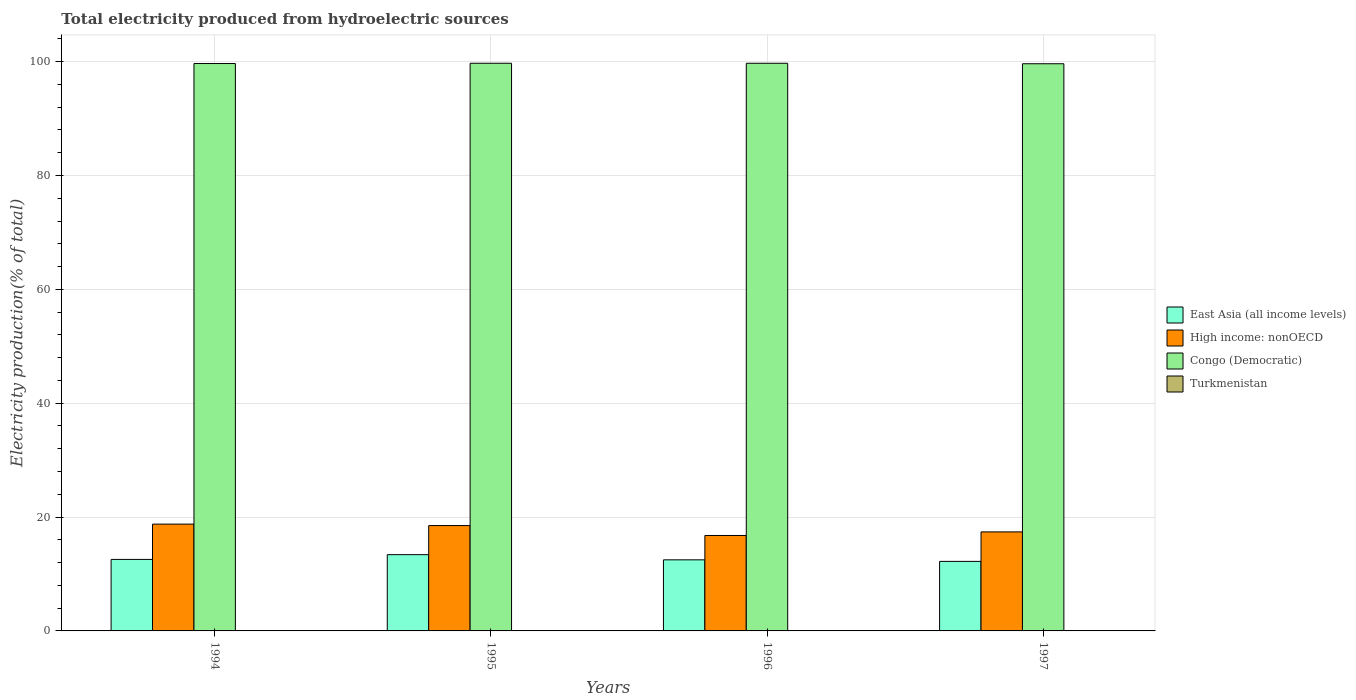How many groups of bars are there?
Provide a succinct answer. 4. Are the number of bars per tick equal to the number of legend labels?
Keep it short and to the point. Yes. How many bars are there on the 2nd tick from the right?
Offer a very short reply. 4. What is the label of the 4th group of bars from the left?
Provide a succinct answer. 1997. What is the total electricity produced in High income: nonOECD in 1995?
Provide a short and direct response. 18.5. Across all years, what is the maximum total electricity produced in High income: nonOECD?
Offer a very short reply. 18.76. Across all years, what is the minimum total electricity produced in Turkmenistan?
Your answer should be compact. 0.04. In which year was the total electricity produced in Congo (Democratic) minimum?
Give a very brief answer. 1997. What is the total total electricity produced in Turkmenistan in the graph?
Your answer should be very brief. 0.18. What is the difference between the total electricity produced in East Asia (all income levels) in 1994 and that in 1996?
Your answer should be compact. 0.08. What is the difference between the total electricity produced in High income: nonOECD in 1997 and the total electricity produced in Turkmenistan in 1995?
Your answer should be compact. 17.35. What is the average total electricity produced in East Asia (all income levels) per year?
Give a very brief answer. 12.66. In the year 1995, what is the difference between the total electricity produced in East Asia (all income levels) and total electricity produced in Congo (Democratic)?
Provide a short and direct response. -86.31. In how many years, is the total electricity produced in Turkmenistan greater than 8 %?
Ensure brevity in your answer.  0. What is the ratio of the total electricity produced in Turkmenistan in 1996 to that in 1997?
Your response must be concise. 0.94. Is the total electricity produced in East Asia (all income levels) in 1995 less than that in 1997?
Your response must be concise. No. Is the difference between the total electricity produced in East Asia (all income levels) in 1994 and 1995 greater than the difference between the total electricity produced in Congo (Democratic) in 1994 and 1995?
Your answer should be compact. No. What is the difference between the highest and the second highest total electricity produced in East Asia (all income levels)?
Your answer should be very brief. 0.83. What is the difference between the highest and the lowest total electricity produced in Turkmenistan?
Make the answer very short. 0.01. Is it the case that in every year, the sum of the total electricity produced in East Asia (all income levels) and total electricity produced in Turkmenistan is greater than the sum of total electricity produced in High income: nonOECD and total electricity produced in Congo (Democratic)?
Provide a short and direct response. No. What does the 2nd bar from the left in 1996 represents?
Your answer should be compact. High income: nonOECD. What does the 4th bar from the right in 1995 represents?
Give a very brief answer. East Asia (all income levels). Is it the case that in every year, the sum of the total electricity produced in High income: nonOECD and total electricity produced in East Asia (all income levels) is greater than the total electricity produced in Congo (Democratic)?
Offer a very short reply. No. How many bars are there?
Offer a very short reply. 16. Does the graph contain grids?
Provide a succinct answer. Yes. Where does the legend appear in the graph?
Your answer should be very brief. Center right. How many legend labels are there?
Make the answer very short. 4. What is the title of the graph?
Give a very brief answer. Total electricity produced from hydroelectric sources. Does "Philippines" appear as one of the legend labels in the graph?
Offer a terse response. No. What is the label or title of the Y-axis?
Provide a succinct answer. Electricity production(% of total). What is the Electricity production(% of total) in East Asia (all income levels) in 1994?
Ensure brevity in your answer.  12.56. What is the Electricity production(% of total) in High income: nonOECD in 1994?
Your answer should be very brief. 18.76. What is the Electricity production(% of total) in Congo (Democratic) in 1994?
Offer a terse response. 99.66. What is the Electricity production(% of total) in Turkmenistan in 1994?
Keep it short and to the point. 0.04. What is the Electricity production(% of total) of East Asia (all income levels) in 1995?
Offer a terse response. 13.39. What is the Electricity production(% of total) in High income: nonOECD in 1995?
Your answer should be very brief. 18.5. What is the Electricity production(% of total) of Congo (Democratic) in 1995?
Make the answer very short. 99.71. What is the Electricity production(% of total) of Turkmenistan in 1995?
Offer a very short reply. 0.04. What is the Electricity production(% of total) in East Asia (all income levels) in 1996?
Keep it short and to the point. 12.48. What is the Electricity production(% of total) of High income: nonOECD in 1996?
Offer a very short reply. 16.76. What is the Electricity production(% of total) in Congo (Democratic) in 1996?
Offer a terse response. 99.71. What is the Electricity production(% of total) in Turkmenistan in 1996?
Offer a terse response. 0.05. What is the Electricity production(% of total) of East Asia (all income levels) in 1997?
Provide a short and direct response. 12.22. What is the Electricity production(% of total) in High income: nonOECD in 1997?
Ensure brevity in your answer.  17.39. What is the Electricity production(% of total) in Congo (Democratic) in 1997?
Offer a very short reply. 99.62. What is the Electricity production(% of total) of Turkmenistan in 1997?
Provide a succinct answer. 0.05. Across all years, what is the maximum Electricity production(% of total) of East Asia (all income levels)?
Provide a short and direct response. 13.39. Across all years, what is the maximum Electricity production(% of total) of High income: nonOECD?
Offer a terse response. 18.76. Across all years, what is the maximum Electricity production(% of total) of Congo (Democratic)?
Your answer should be very brief. 99.71. Across all years, what is the maximum Electricity production(% of total) in Turkmenistan?
Ensure brevity in your answer.  0.05. Across all years, what is the minimum Electricity production(% of total) in East Asia (all income levels)?
Offer a terse response. 12.22. Across all years, what is the minimum Electricity production(% of total) of High income: nonOECD?
Your response must be concise. 16.76. Across all years, what is the minimum Electricity production(% of total) of Congo (Democratic)?
Give a very brief answer. 99.62. Across all years, what is the minimum Electricity production(% of total) of Turkmenistan?
Your answer should be compact. 0.04. What is the total Electricity production(% of total) of East Asia (all income levels) in the graph?
Give a very brief answer. 50.66. What is the total Electricity production(% of total) in High income: nonOECD in the graph?
Offer a terse response. 71.42. What is the total Electricity production(% of total) of Congo (Democratic) in the graph?
Offer a very short reply. 398.7. What is the total Electricity production(% of total) of Turkmenistan in the graph?
Ensure brevity in your answer.  0.18. What is the difference between the Electricity production(% of total) of East Asia (all income levels) in 1994 and that in 1995?
Give a very brief answer. -0.83. What is the difference between the Electricity production(% of total) of High income: nonOECD in 1994 and that in 1995?
Your answer should be compact. 0.26. What is the difference between the Electricity production(% of total) in Congo (Democratic) in 1994 and that in 1995?
Give a very brief answer. -0.05. What is the difference between the Electricity production(% of total) in Turkmenistan in 1994 and that in 1995?
Provide a short and direct response. -0. What is the difference between the Electricity production(% of total) in East Asia (all income levels) in 1994 and that in 1996?
Make the answer very short. 0.08. What is the difference between the Electricity production(% of total) in High income: nonOECD in 1994 and that in 1996?
Offer a very short reply. 2. What is the difference between the Electricity production(% of total) of Congo (Democratic) in 1994 and that in 1996?
Offer a very short reply. -0.04. What is the difference between the Electricity production(% of total) in Turkmenistan in 1994 and that in 1996?
Give a very brief answer. -0.01. What is the difference between the Electricity production(% of total) in East Asia (all income levels) in 1994 and that in 1997?
Your answer should be compact. 0.35. What is the difference between the Electricity production(% of total) in High income: nonOECD in 1994 and that in 1997?
Offer a terse response. 1.37. What is the difference between the Electricity production(% of total) of Congo (Democratic) in 1994 and that in 1997?
Make the answer very short. 0.04. What is the difference between the Electricity production(% of total) in Turkmenistan in 1994 and that in 1997?
Ensure brevity in your answer.  -0.01. What is the difference between the Electricity production(% of total) of East Asia (all income levels) in 1995 and that in 1996?
Your answer should be compact. 0.91. What is the difference between the Electricity production(% of total) of High income: nonOECD in 1995 and that in 1996?
Your response must be concise. 1.74. What is the difference between the Electricity production(% of total) of Congo (Democratic) in 1995 and that in 1996?
Your response must be concise. 0. What is the difference between the Electricity production(% of total) of Turkmenistan in 1995 and that in 1996?
Keep it short and to the point. -0.01. What is the difference between the Electricity production(% of total) of East Asia (all income levels) in 1995 and that in 1997?
Ensure brevity in your answer.  1.18. What is the difference between the Electricity production(% of total) of High income: nonOECD in 1995 and that in 1997?
Your answer should be very brief. 1.11. What is the difference between the Electricity production(% of total) in Congo (Democratic) in 1995 and that in 1997?
Make the answer very short. 0.09. What is the difference between the Electricity production(% of total) of Turkmenistan in 1995 and that in 1997?
Your answer should be compact. -0.01. What is the difference between the Electricity production(% of total) in East Asia (all income levels) in 1996 and that in 1997?
Provide a succinct answer. 0.27. What is the difference between the Electricity production(% of total) of High income: nonOECD in 1996 and that in 1997?
Keep it short and to the point. -0.63. What is the difference between the Electricity production(% of total) of Congo (Democratic) in 1996 and that in 1997?
Keep it short and to the point. 0.08. What is the difference between the Electricity production(% of total) in Turkmenistan in 1996 and that in 1997?
Provide a succinct answer. -0. What is the difference between the Electricity production(% of total) in East Asia (all income levels) in 1994 and the Electricity production(% of total) in High income: nonOECD in 1995?
Offer a terse response. -5.94. What is the difference between the Electricity production(% of total) of East Asia (all income levels) in 1994 and the Electricity production(% of total) of Congo (Democratic) in 1995?
Give a very brief answer. -87.15. What is the difference between the Electricity production(% of total) in East Asia (all income levels) in 1994 and the Electricity production(% of total) in Turkmenistan in 1995?
Offer a very short reply. 12.52. What is the difference between the Electricity production(% of total) in High income: nonOECD in 1994 and the Electricity production(% of total) in Congo (Democratic) in 1995?
Give a very brief answer. -80.95. What is the difference between the Electricity production(% of total) of High income: nonOECD in 1994 and the Electricity production(% of total) of Turkmenistan in 1995?
Provide a short and direct response. 18.72. What is the difference between the Electricity production(% of total) of Congo (Democratic) in 1994 and the Electricity production(% of total) of Turkmenistan in 1995?
Provide a succinct answer. 99.62. What is the difference between the Electricity production(% of total) of East Asia (all income levels) in 1994 and the Electricity production(% of total) of High income: nonOECD in 1996?
Ensure brevity in your answer.  -4.2. What is the difference between the Electricity production(% of total) in East Asia (all income levels) in 1994 and the Electricity production(% of total) in Congo (Democratic) in 1996?
Keep it short and to the point. -87.14. What is the difference between the Electricity production(% of total) in East Asia (all income levels) in 1994 and the Electricity production(% of total) in Turkmenistan in 1996?
Your answer should be compact. 12.51. What is the difference between the Electricity production(% of total) of High income: nonOECD in 1994 and the Electricity production(% of total) of Congo (Democratic) in 1996?
Keep it short and to the point. -80.95. What is the difference between the Electricity production(% of total) in High income: nonOECD in 1994 and the Electricity production(% of total) in Turkmenistan in 1996?
Offer a terse response. 18.71. What is the difference between the Electricity production(% of total) in Congo (Democratic) in 1994 and the Electricity production(% of total) in Turkmenistan in 1996?
Ensure brevity in your answer.  99.61. What is the difference between the Electricity production(% of total) in East Asia (all income levels) in 1994 and the Electricity production(% of total) in High income: nonOECD in 1997?
Your answer should be very brief. -4.83. What is the difference between the Electricity production(% of total) of East Asia (all income levels) in 1994 and the Electricity production(% of total) of Congo (Democratic) in 1997?
Ensure brevity in your answer.  -87.06. What is the difference between the Electricity production(% of total) in East Asia (all income levels) in 1994 and the Electricity production(% of total) in Turkmenistan in 1997?
Your answer should be very brief. 12.51. What is the difference between the Electricity production(% of total) of High income: nonOECD in 1994 and the Electricity production(% of total) of Congo (Democratic) in 1997?
Keep it short and to the point. -80.86. What is the difference between the Electricity production(% of total) in High income: nonOECD in 1994 and the Electricity production(% of total) in Turkmenistan in 1997?
Provide a short and direct response. 18.71. What is the difference between the Electricity production(% of total) of Congo (Democratic) in 1994 and the Electricity production(% of total) of Turkmenistan in 1997?
Your answer should be very brief. 99.61. What is the difference between the Electricity production(% of total) of East Asia (all income levels) in 1995 and the Electricity production(% of total) of High income: nonOECD in 1996?
Ensure brevity in your answer.  -3.37. What is the difference between the Electricity production(% of total) of East Asia (all income levels) in 1995 and the Electricity production(% of total) of Congo (Democratic) in 1996?
Provide a short and direct response. -86.31. What is the difference between the Electricity production(% of total) in East Asia (all income levels) in 1995 and the Electricity production(% of total) in Turkmenistan in 1996?
Make the answer very short. 13.34. What is the difference between the Electricity production(% of total) of High income: nonOECD in 1995 and the Electricity production(% of total) of Congo (Democratic) in 1996?
Your response must be concise. -81.2. What is the difference between the Electricity production(% of total) of High income: nonOECD in 1995 and the Electricity production(% of total) of Turkmenistan in 1996?
Offer a terse response. 18.45. What is the difference between the Electricity production(% of total) of Congo (Democratic) in 1995 and the Electricity production(% of total) of Turkmenistan in 1996?
Make the answer very short. 99.66. What is the difference between the Electricity production(% of total) of East Asia (all income levels) in 1995 and the Electricity production(% of total) of High income: nonOECD in 1997?
Your answer should be compact. -4. What is the difference between the Electricity production(% of total) in East Asia (all income levels) in 1995 and the Electricity production(% of total) in Congo (Democratic) in 1997?
Provide a succinct answer. -86.23. What is the difference between the Electricity production(% of total) in East Asia (all income levels) in 1995 and the Electricity production(% of total) in Turkmenistan in 1997?
Keep it short and to the point. 13.34. What is the difference between the Electricity production(% of total) in High income: nonOECD in 1995 and the Electricity production(% of total) in Congo (Democratic) in 1997?
Make the answer very short. -81.12. What is the difference between the Electricity production(% of total) in High income: nonOECD in 1995 and the Electricity production(% of total) in Turkmenistan in 1997?
Make the answer very short. 18.45. What is the difference between the Electricity production(% of total) in Congo (Democratic) in 1995 and the Electricity production(% of total) in Turkmenistan in 1997?
Give a very brief answer. 99.66. What is the difference between the Electricity production(% of total) of East Asia (all income levels) in 1996 and the Electricity production(% of total) of High income: nonOECD in 1997?
Your answer should be compact. -4.91. What is the difference between the Electricity production(% of total) in East Asia (all income levels) in 1996 and the Electricity production(% of total) in Congo (Democratic) in 1997?
Your response must be concise. -87.14. What is the difference between the Electricity production(% of total) of East Asia (all income levels) in 1996 and the Electricity production(% of total) of Turkmenistan in 1997?
Your answer should be compact. 12.43. What is the difference between the Electricity production(% of total) in High income: nonOECD in 1996 and the Electricity production(% of total) in Congo (Democratic) in 1997?
Give a very brief answer. -82.86. What is the difference between the Electricity production(% of total) of High income: nonOECD in 1996 and the Electricity production(% of total) of Turkmenistan in 1997?
Provide a short and direct response. 16.71. What is the difference between the Electricity production(% of total) in Congo (Democratic) in 1996 and the Electricity production(% of total) in Turkmenistan in 1997?
Your answer should be compact. 99.65. What is the average Electricity production(% of total) in East Asia (all income levels) per year?
Offer a terse response. 12.66. What is the average Electricity production(% of total) in High income: nonOECD per year?
Keep it short and to the point. 17.85. What is the average Electricity production(% of total) in Congo (Democratic) per year?
Offer a terse response. 99.67. What is the average Electricity production(% of total) in Turkmenistan per year?
Your answer should be compact. 0.05. In the year 1994, what is the difference between the Electricity production(% of total) of East Asia (all income levels) and Electricity production(% of total) of High income: nonOECD?
Keep it short and to the point. -6.2. In the year 1994, what is the difference between the Electricity production(% of total) in East Asia (all income levels) and Electricity production(% of total) in Congo (Democratic)?
Your answer should be compact. -87.1. In the year 1994, what is the difference between the Electricity production(% of total) in East Asia (all income levels) and Electricity production(% of total) in Turkmenistan?
Offer a terse response. 12.52. In the year 1994, what is the difference between the Electricity production(% of total) of High income: nonOECD and Electricity production(% of total) of Congo (Democratic)?
Provide a short and direct response. -80.9. In the year 1994, what is the difference between the Electricity production(% of total) in High income: nonOECD and Electricity production(% of total) in Turkmenistan?
Your answer should be very brief. 18.72. In the year 1994, what is the difference between the Electricity production(% of total) in Congo (Democratic) and Electricity production(% of total) in Turkmenistan?
Your answer should be compact. 99.62. In the year 1995, what is the difference between the Electricity production(% of total) of East Asia (all income levels) and Electricity production(% of total) of High income: nonOECD?
Your response must be concise. -5.11. In the year 1995, what is the difference between the Electricity production(% of total) in East Asia (all income levels) and Electricity production(% of total) in Congo (Democratic)?
Give a very brief answer. -86.31. In the year 1995, what is the difference between the Electricity production(% of total) in East Asia (all income levels) and Electricity production(% of total) in Turkmenistan?
Provide a succinct answer. 13.35. In the year 1995, what is the difference between the Electricity production(% of total) in High income: nonOECD and Electricity production(% of total) in Congo (Democratic)?
Your answer should be compact. -81.2. In the year 1995, what is the difference between the Electricity production(% of total) in High income: nonOECD and Electricity production(% of total) in Turkmenistan?
Offer a very short reply. 18.46. In the year 1995, what is the difference between the Electricity production(% of total) in Congo (Democratic) and Electricity production(% of total) in Turkmenistan?
Keep it short and to the point. 99.67. In the year 1996, what is the difference between the Electricity production(% of total) of East Asia (all income levels) and Electricity production(% of total) of High income: nonOECD?
Provide a short and direct response. -4.28. In the year 1996, what is the difference between the Electricity production(% of total) of East Asia (all income levels) and Electricity production(% of total) of Congo (Democratic)?
Provide a succinct answer. -87.22. In the year 1996, what is the difference between the Electricity production(% of total) of East Asia (all income levels) and Electricity production(% of total) of Turkmenistan?
Keep it short and to the point. 12.44. In the year 1996, what is the difference between the Electricity production(% of total) in High income: nonOECD and Electricity production(% of total) in Congo (Democratic)?
Ensure brevity in your answer.  -82.94. In the year 1996, what is the difference between the Electricity production(% of total) in High income: nonOECD and Electricity production(% of total) in Turkmenistan?
Provide a short and direct response. 16.71. In the year 1996, what is the difference between the Electricity production(% of total) of Congo (Democratic) and Electricity production(% of total) of Turkmenistan?
Provide a short and direct response. 99.66. In the year 1997, what is the difference between the Electricity production(% of total) of East Asia (all income levels) and Electricity production(% of total) of High income: nonOECD?
Your answer should be very brief. -5.18. In the year 1997, what is the difference between the Electricity production(% of total) of East Asia (all income levels) and Electricity production(% of total) of Congo (Democratic)?
Your answer should be compact. -87.41. In the year 1997, what is the difference between the Electricity production(% of total) of East Asia (all income levels) and Electricity production(% of total) of Turkmenistan?
Provide a short and direct response. 12.16. In the year 1997, what is the difference between the Electricity production(% of total) of High income: nonOECD and Electricity production(% of total) of Congo (Democratic)?
Your answer should be very brief. -82.23. In the year 1997, what is the difference between the Electricity production(% of total) in High income: nonOECD and Electricity production(% of total) in Turkmenistan?
Keep it short and to the point. 17.34. In the year 1997, what is the difference between the Electricity production(% of total) of Congo (Democratic) and Electricity production(% of total) of Turkmenistan?
Provide a short and direct response. 99.57. What is the ratio of the Electricity production(% of total) in East Asia (all income levels) in 1994 to that in 1995?
Provide a succinct answer. 0.94. What is the ratio of the Electricity production(% of total) in High income: nonOECD in 1994 to that in 1995?
Your response must be concise. 1.01. What is the ratio of the Electricity production(% of total) of Turkmenistan in 1994 to that in 1995?
Offer a terse response. 0.93. What is the ratio of the Electricity production(% of total) of East Asia (all income levels) in 1994 to that in 1996?
Keep it short and to the point. 1.01. What is the ratio of the Electricity production(% of total) of High income: nonOECD in 1994 to that in 1996?
Offer a terse response. 1.12. What is the ratio of the Electricity production(% of total) of Turkmenistan in 1994 to that in 1996?
Offer a very short reply. 0.77. What is the ratio of the Electricity production(% of total) in East Asia (all income levels) in 1994 to that in 1997?
Keep it short and to the point. 1.03. What is the ratio of the Electricity production(% of total) in High income: nonOECD in 1994 to that in 1997?
Give a very brief answer. 1.08. What is the ratio of the Electricity production(% of total) in Turkmenistan in 1994 to that in 1997?
Ensure brevity in your answer.  0.72. What is the ratio of the Electricity production(% of total) of East Asia (all income levels) in 1995 to that in 1996?
Your response must be concise. 1.07. What is the ratio of the Electricity production(% of total) in High income: nonOECD in 1995 to that in 1996?
Provide a short and direct response. 1.1. What is the ratio of the Electricity production(% of total) in Congo (Democratic) in 1995 to that in 1996?
Your answer should be very brief. 1. What is the ratio of the Electricity production(% of total) in Turkmenistan in 1995 to that in 1996?
Provide a succinct answer. 0.82. What is the ratio of the Electricity production(% of total) in East Asia (all income levels) in 1995 to that in 1997?
Provide a short and direct response. 1.1. What is the ratio of the Electricity production(% of total) of High income: nonOECD in 1995 to that in 1997?
Make the answer very short. 1.06. What is the ratio of the Electricity production(% of total) in Congo (Democratic) in 1995 to that in 1997?
Ensure brevity in your answer.  1. What is the ratio of the Electricity production(% of total) in Turkmenistan in 1995 to that in 1997?
Provide a succinct answer. 0.78. What is the ratio of the Electricity production(% of total) in East Asia (all income levels) in 1996 to that in 1997?
Provide a succinct answer. 1.02. What is the ratio of the Electricity production(% of total) in High income: nonOECD in 1996 to that in 1997?
Your response must be concise. 0.96. What is the ratio of the Electricity production(% of total) of Turkmenistan in 1996 to that in 1997?
Your answer should be very brief. 0.94. What is the difference between the highest and the second highest Electricity production(% of total) of East Asia (all income levels)?
Ensure brevity in your answer.  0.83. What is the difference between the highest and the second highest Electricity production(% of total) in High income: nonOECD?
Offer a terse response. 0.26. What is the difference between the highest and the second highest Electricity production(% of total) of Congo (Democratic)?
Provide a short and direct response. 0. What is the difference between the highest and the second highest Electricity production(% of total) in Turkmenistan?
Your answer should be very brief. 0. What is the difference between the highest and the lowest Electricity production(% of total) of East Asia (all income levels)?
Give a very brief answer. 1.18. What is the difference between the highest and the lowest Electricity production(% of total) of High income: nonOECD?
Provide a succinct answer. 2. What is the difference between the highest and the lowest Electricity production(% of total) in Congo (Democratic)?
Keep it short and to the point. 0.09. What is the difference between the highest and the lowest Electricity production(% of total) of Turkmenistan?
Give a very brief answer. 0.01. 